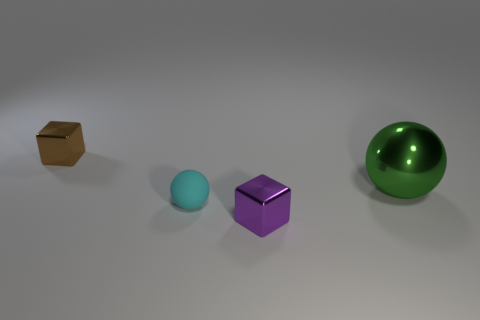There is another thing that is the same shape as the green shiny thing; what is its color?
Offer a very short reply. Cyan. Is the material of the sphere that is on the left side of the purple metallic cube the same as the small brown thing?
Your answer should be very brief. No. How many tiny objects are metallic cubes or green objects?
Your answer should be compact. 2. The metallic ball has what size?
Keep it short and to the point. Large. Do the purple shiny cube and the green object behind the small sphere have the same size?
Your answer should be compact. No. How many green things are either big cubes or large metal spheres?
Your answer should be compact. 1. What number of yellow metal blocks are there?
Offer a terse response. 0. What is the size of the thing that is right of the tiny purple block?
Your answer should be very brief. Large. Does the cyan matte object have the same size as the brown block?
Provide a succinct answer. Yes. How many things are either large green balls or things that are left of the large green metallic thing?
Provide a short and direct response. 4. 